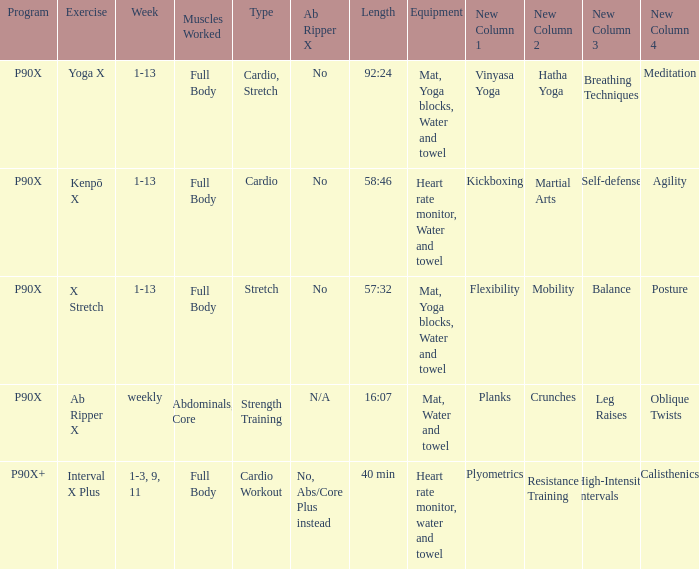What does the term "ab ripper x" mean when given a length of 92:24? No. Give me the full table as a dictionary. {'header': ['Program', 'Exercise', 'Week', 'Muscles Worked', 'Type', 'Ab Ripper X', 'Length', 'Equipment', 'New Column 1', 'New Column 2', 'New Column 3', 'New Column 4'], 'rows': [['P90X', 'Yoga X', '1-13', 'Full Body', 'Cardio, Stretch', 'No', '92:24', 'Mat, Yoga blocks, Water and towel', 'Vinyasa Yoga', 'Hatha Yoga', 'Breathing Techniques', 'Meditation'], ['P90X', 'Kenpō X', '1-13', 'Full Body', 'Cardio', 'No', '58:46', 'Heart rate monitor, Water and towel', 'Kickboxing', 'Martial Arts', 'Self-defense', 'Agility'], ['P90X', 'X Stretch', '1-13', 'Full Body', 'Stretch', 'No', '57:32', 'Mat, Yoga blocks, Water and towel', 'Flexibility', 'Mobility', 'Balance', 'Posture'], ['P90X', 'Ab Ripper X', 'weekly', 'Abdominals, Core', 'Strength Training', 'N/A', '16:07', 'Mat, Water and towel', 'Planks', 'Crunches', 'Leg Raises', 'Oblique Twists'], ['P90X+', 'Interval X Plus', '1-3, 9, 11', 'Full Body', 'Cardio Workout', 'No, Abs/Core Plus instead', '40 min', 'Heart rate monitor, water and towel', 'Plyometrics', 'Resistance Training', 'High-Intensity Intervals', 'Calisthenics']]} 